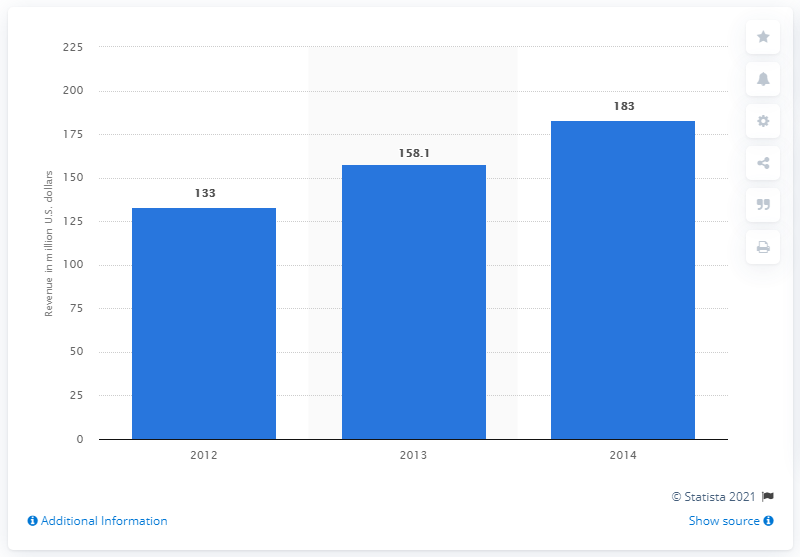Identify some key points in this picture. In 2014, the estimated amount of online game revenue for PCs in Thailand was approximately 183.. 